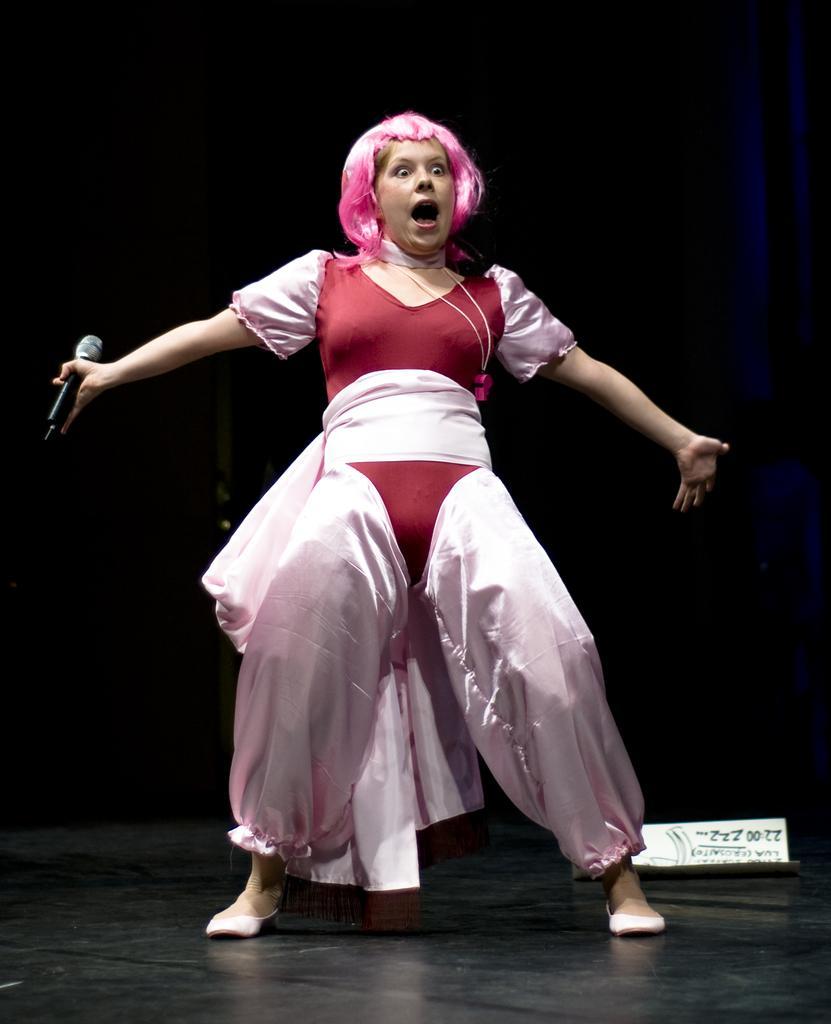Please provide a concise description of this image. In this picture there is a woman who is wearing red and pink color dress and holding a mic. She is also wearing pink color hairs and shoe. She is standing on the stage. On the back we can see a dark. 